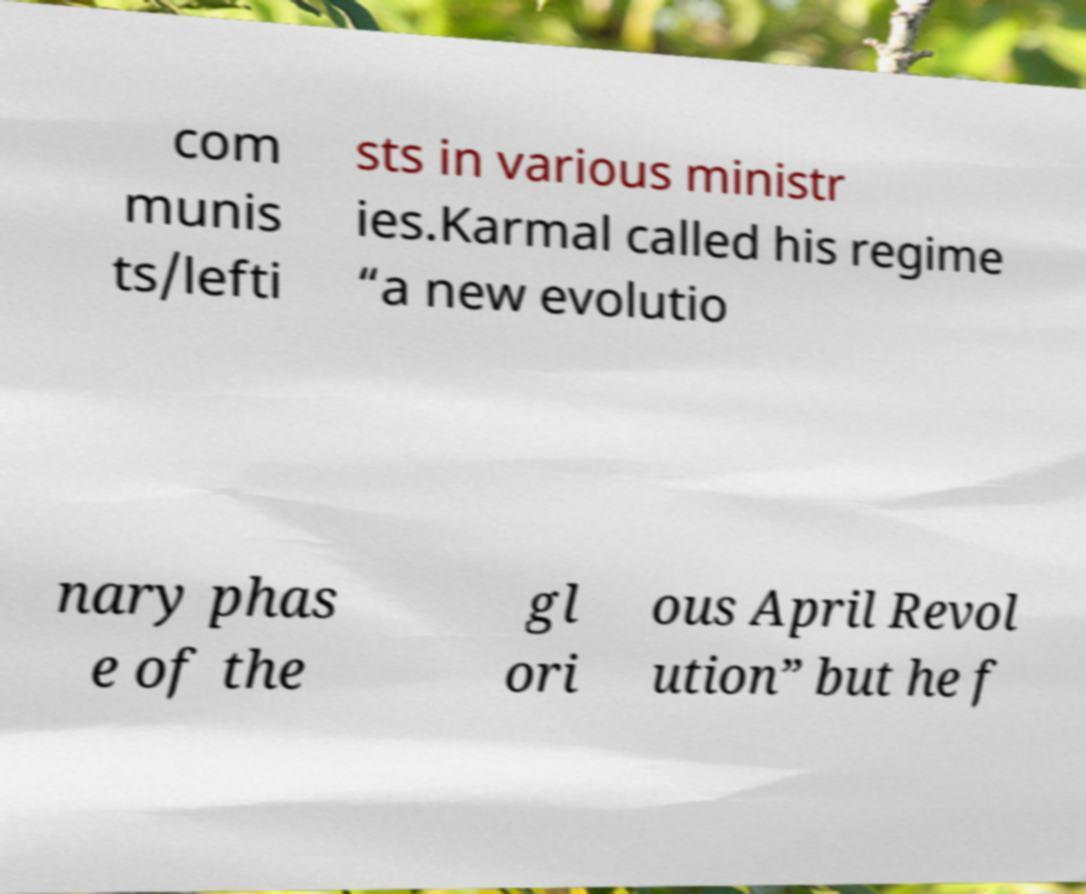Could you extract and type out the text from this image? com munis ts/lefti sts in various ministr ies.Karmal called his regime “a new evolutio nary phas e of the gl ori ous April Revol ution” but he f 